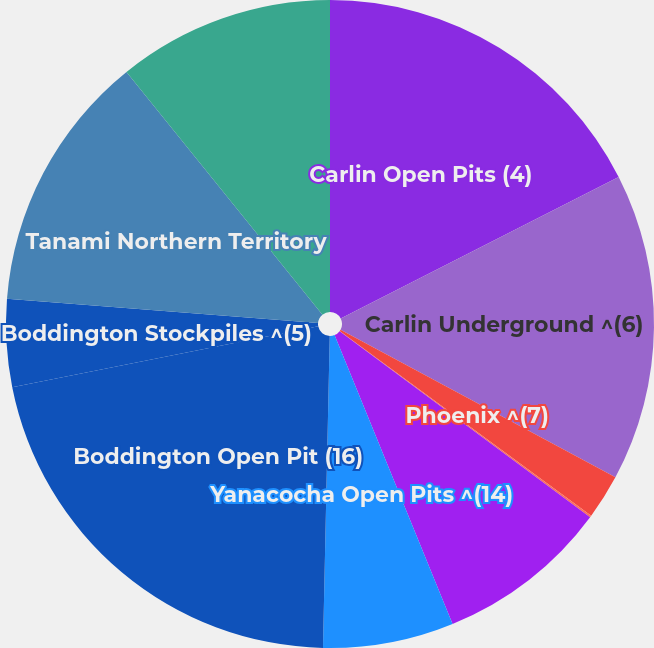Convert chart. <chart><loc_0><loc_0><loc_500><loc_500><pie_chart><fcel>Carlin Open Pits (4)<fcel>Carlin Underground ^(6)<fcel>Phoenix ^(7)<fcel>Lone Tree ^(8)<fcel>Turquoise Ridge ^(9)<fcel>Yanacocha Open Pits ^(14)<fcel>Boddington Open Pit (16)<fcel>Boddington Stockpiles ^(5)<fcel>Tanami Northern Territory<fcel>Ahafo South Open Pits ^(19)<nl><fcel>17.5%<fcel>15.35%<fcel>2.23%<fcel>0.09%<fcel>8.66%<fcel>6.52%<fcel>21.53%<fcel>4.37%<fcel>12.95%<fcel>10.81%<nl></chart> 